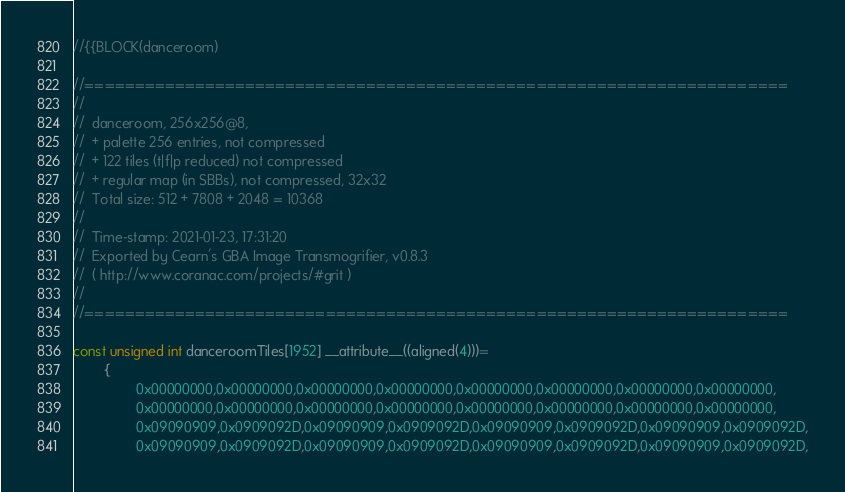Convert code to text. <code><loc_0><loc_0><loc_500><loc_500><_C_>
//{{BLOCK(danceroom)

//======================================================================
//
//	danceroom, 256x256@8,
//	+ palette 256 entries, not compressed
//	+ 122 tiles (t|f|p reduced) not compressed
//	+ regular map (in SBBs), not compressed, 32x32
//	Total size: 512 + 7808 + 2048 = 10368
//
//	Time-stamp: 2021-01-23, 17:31:20
//	Exported by Cearn's GBA Image Transmogrifier, v0.8.3
//	( http://www.coranac.com/projects/#grit )
//
//======================================================================

const unsigned int danceroomTiles[1952] __attribute__((aligned(4)))=
        {
                0x00000000,0x00000000,0x00000000,0x00000000,0x00000000,0x00000000,0x00000000,0x00000000,
                0x00000000,0x00000000,0x00000000,0x00000000,0x00000000,0x00000000,0x00000000,0x00000000,
                0x09090909,0x0909092D,0x09090909,0x0909092D,0x09090909,0x0909092D,0x09090909,0x0909092D,
                0x09090909,0x0909092D,0x09090909,0x0909092D,0x09090909,0x0909092D,0x09090909,0x0909092D,</code> 